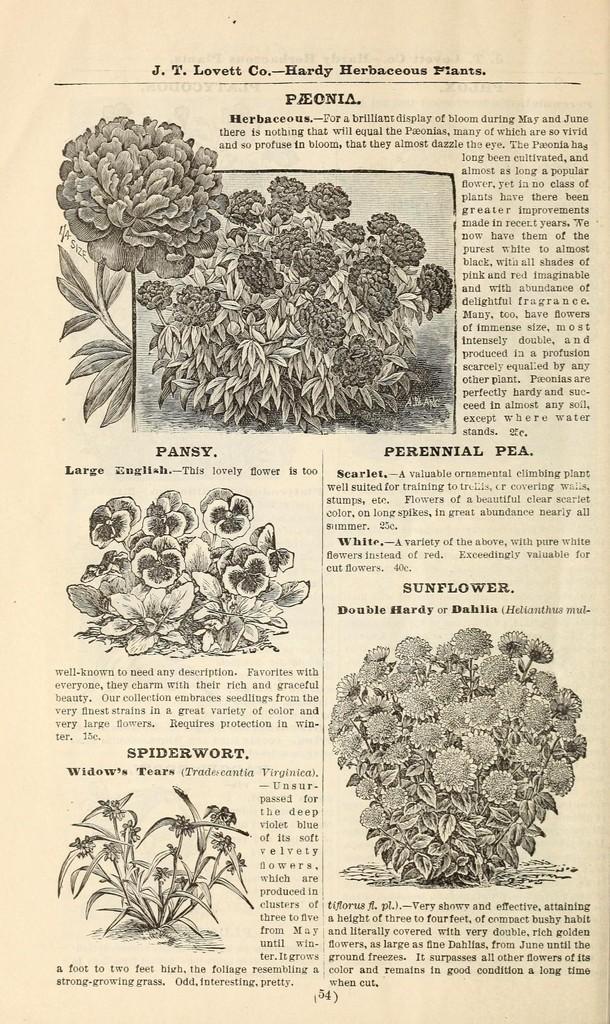Describe this image in one or two sentences. In this picture there is plants poster in the image. 